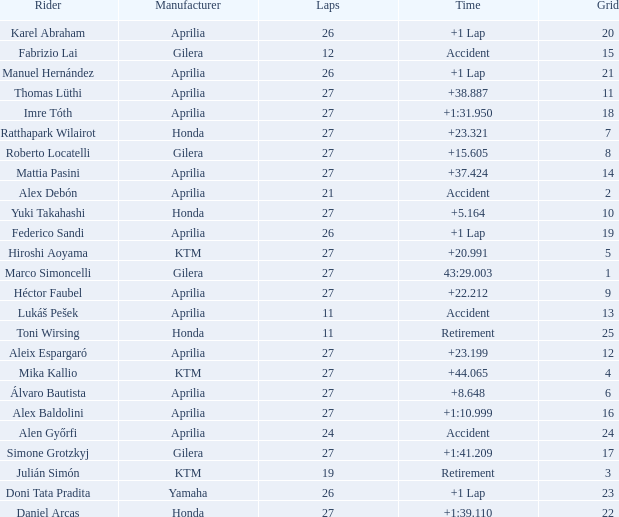Which Manufacturer has a Time of accident and a Grid greater than 15? Aprilia. 